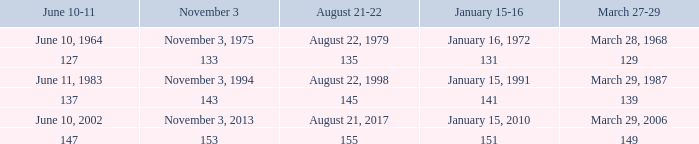What is the number for march 27-29 whern november 3 is 153? 149.0. 